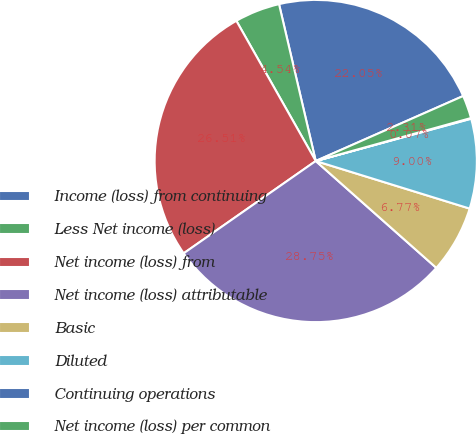Convert chart. <chart><loc_0><loc_0><loc_500><loc_500><pie_chart><fcel>Income (loss) from continuing<fcel>Less Net income (loss)<fcel>Net income (loss) from<fcel>Net income (loss) attributable<fcel>Basic<fcel>Diluted<fcel>Continuing operations<fcel>Net income (loss) per common<nl><fcel>22.05%<fcel>4.54%<fcel>26.51%<fcel>28.75%<fcel>6.77%<fcel>9.0%<fcel>0.07%<fcel>2.31%<nl></chart> 